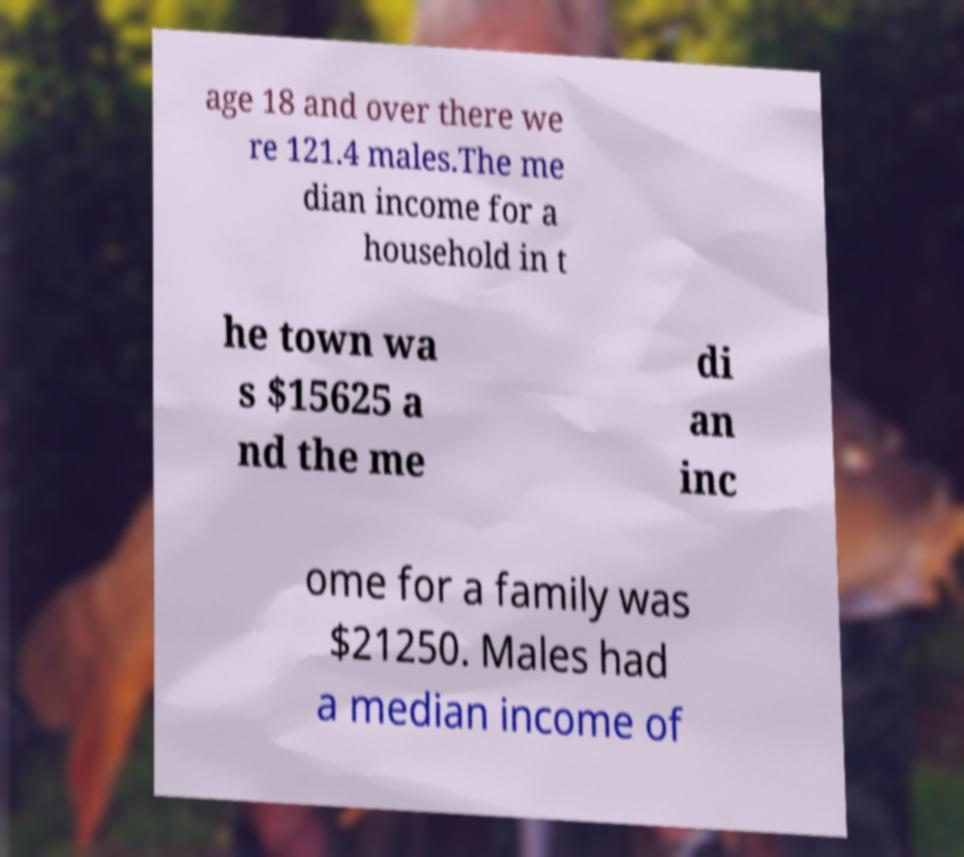There's text embedded in this image that I need extracted. Can you transcribe it verbatim? age 18 and over there we re 121.4 males.The me dian income for a household in t he town wa s $15625 a nd the me di an inc ome for a family was $21250. Males had a median income of 